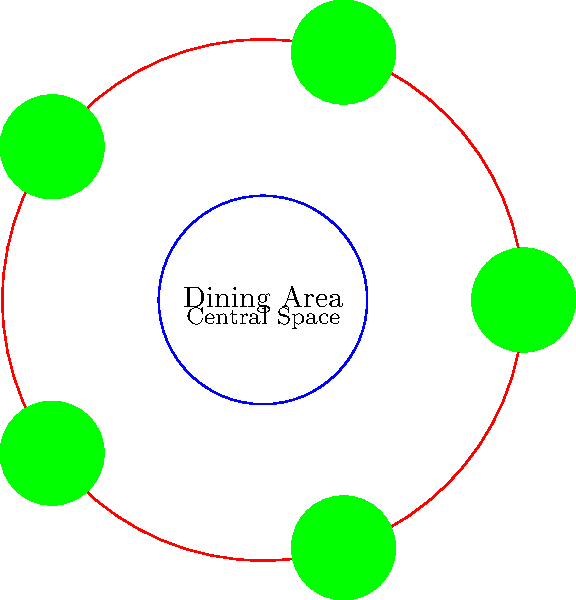As a restaurant owner, you're redesigning a circular dining area with a radius of 10 meters. You want to place circular tables with a 2-meter diameter around the perimeter, leaving a central circular space with a 4-meter diameter for staff movement. What is the maximum number of tables that can fit in this arrangement while maintaining at least 0.5 meters of space between adjacent tables? Let's approach this step-by-step:

1) The radius of the dining area is 10 meters, so its circumference is:
   $C = 2\pi r = 2\pi(10) = 20\pi$ meters

2) The central space has a diameter of 4 meters, so its radius is 2 meters. This leaves an 8-meter wide ring for table placement.

3) Each table has a diameter of 2 meters, so it occupies 2 meters of the circumference.

4) We need at least 0.5 meters between tables. So each table, including its spacing, occupies 2.5 meters of the circumference.

5) The number of tables that can fit is the circumference divided by the space each table occupies:
   $N = \frac{20\pi}{2.5} \approx 25.13$

6) Since we can't have a fractional number of tables, we round down to 25.

7) To verify:
   25 tables * 2.5 meters = 62.5 meters
   Circumference = $20\pi \approx 62.83$ meters
   This leaves about 0.33 meters of extra space, which when distributed, ensures more than 0.5 meters between each table.
Answer: 25 tables 